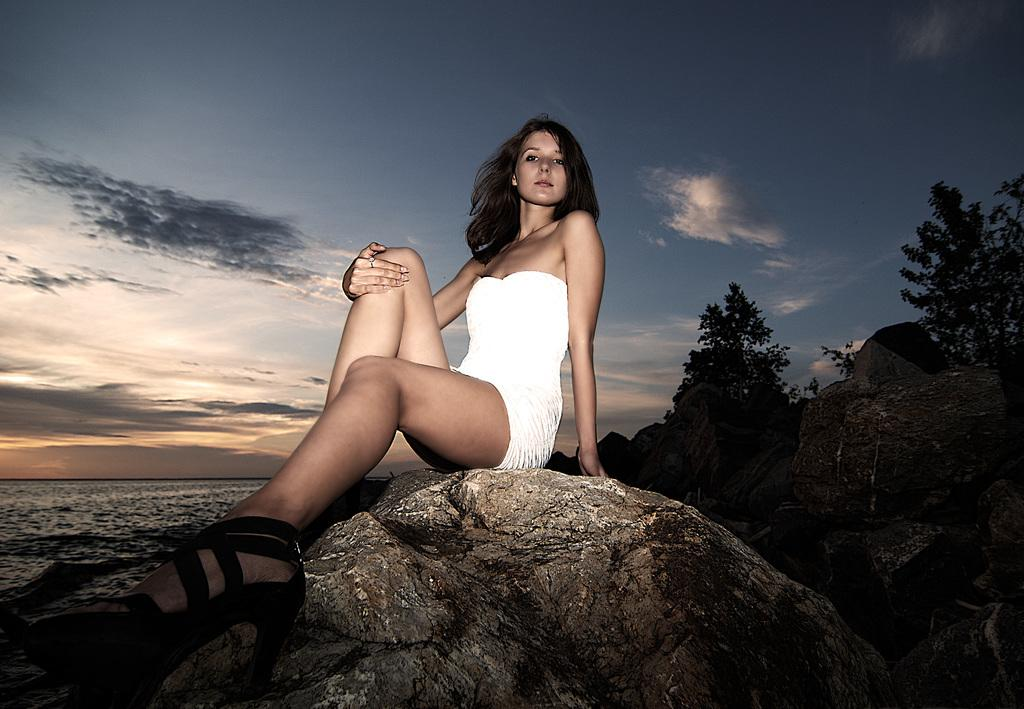What is the woman doing in the image? The woman is sitting on a rock in the image. What type of natural environment is visible in the image? There are trees, water, and rocks visible in the image. What can be seen in the background of the image? The sky with clouds is visible in the background of the image. What type of beast is polishing its claws in the image? There is no beast present in the image, and therefore no such activity can be observed. 